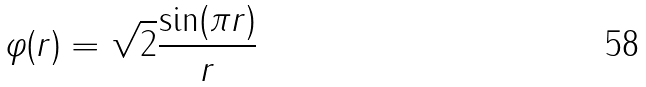<formula> <loc_0><loc_0><loc_500><loc_500>\varphi ( r ) = \sqrt { 2 } \frac { \sin ( \pi r ) } { r }</formula> 